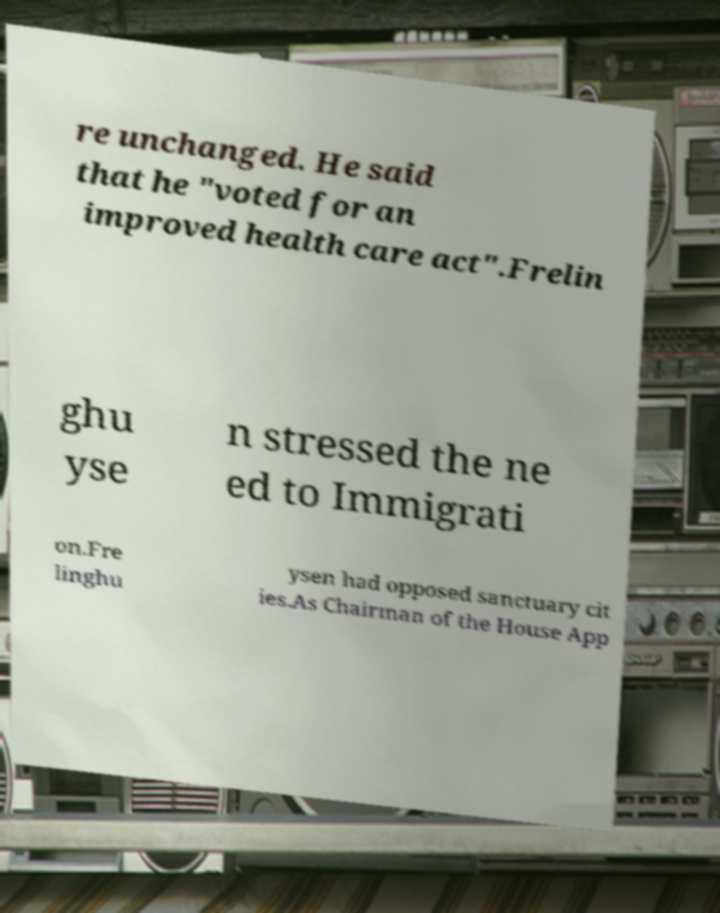Please identify and transcribe the text found in this image. re unchanged. He said that he "voted for an improved health care act".Frelin ghu yse n stressed the ne ed to Immigrati on.Fre linghu ysen had opposed sanctuary cit ies.As Chairman of the House App 